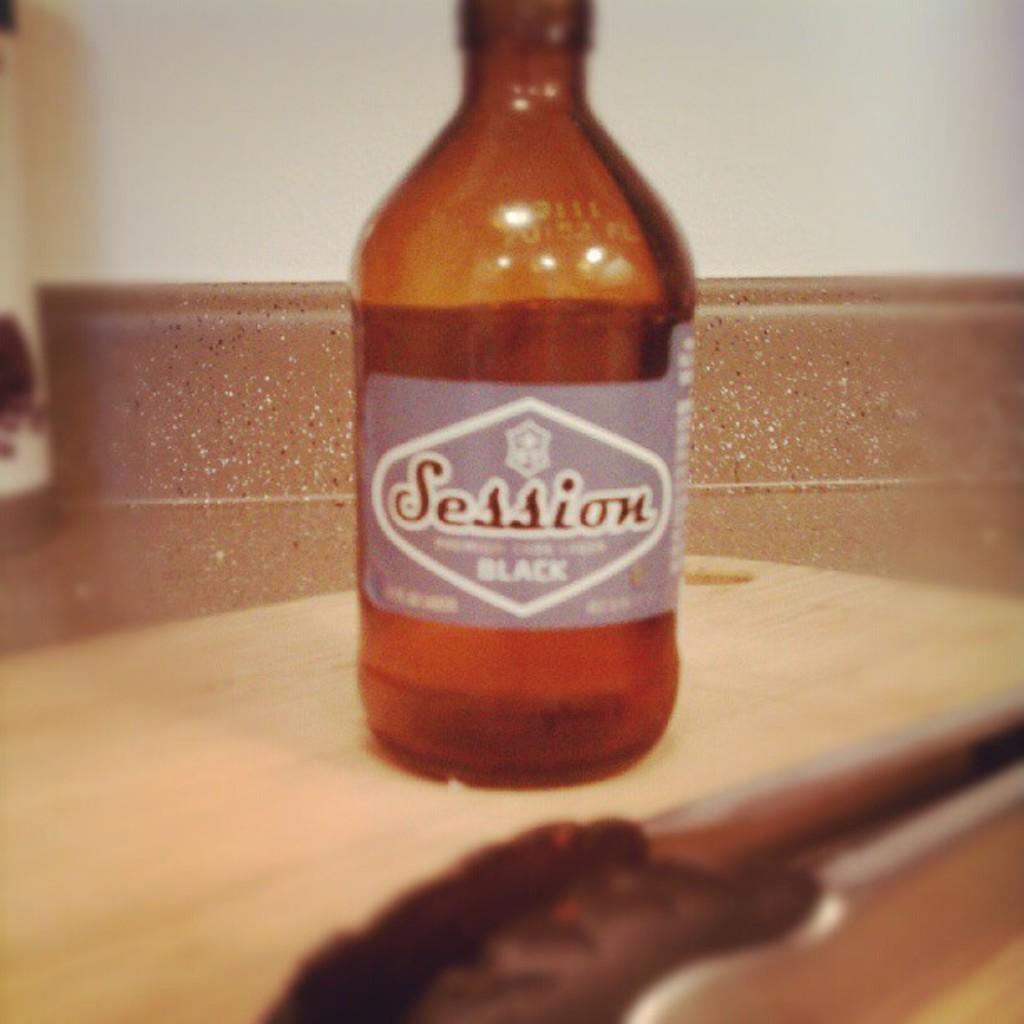Please provide a concise description of this image. In this picture we can see an object, bottle on a table and in the background we can see the wall. 